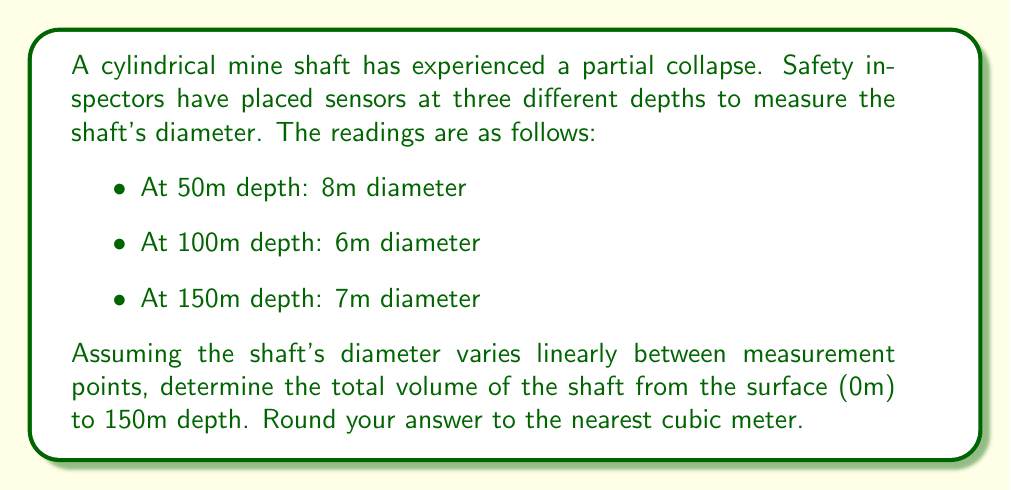Could you help me with this problem? To solve this problem, we'll follow these steps:

1) First, we need to determine the diameter at the surface (0m depth). We can do this by extrapolating the line between the first two measurements:

   $\frac{8m - 6m}{50m - 100m} = \frac{x - 8m}{0m - 50m}$

   $\frac{2m}{-50m} = \frac{x - 8m}{-50m}$

   $x - 8m = 2m$
   $x = 10m$

2) Now we have four points defining three sections of the shaft:
   - 0m to 50m: diameter changes from 10m to 8m
   - 50m to 100m: diameter changes from 8m to 6m
   - 100m to 150m: diameter changes from 6m to 7m

3) For each section, we can use the formula for the volume of a truncated cone:
   
   $V = \frac{1}{3}\pi h(R^2 + r^2 + Rr)$

   where $h$ is the height, $R$ is the radius at the base, and $r$ is the radius at the top.

4) Let's calculate the volume for each section:

   Section 1 (0m to 50m):
   $V_1 = \frac{1}{3}\pi \cdot 50 \cdot ((5^2 + 4^2 + 5 \cdot 4) = \frac{1}{3}\pi \cdot 50 \cdot 61 = 3189.14m^3$

   Section 2 (50m to 100m):
   $V_2 = \frac{1}{3}\pi \cdot 50 \cdot ((4^2 + 3^2 + 4 \cdot 3) = \frac{1}{3}\pi \cdot 50 \cdot 37 = 1932.08m^3$

   Section 3 (100m to 150m):
   $V_3 = \frac{1}{3}\pi \cdot 50 \cdot ((3^2 + 3.5^2 + 3 \cdot 3.5) = \frac{1}{3}\pi \cdot 50 \cdot 31.75 = 1658.12m^3$

5) The total volume is the sum of these three sections:

   $V_{total} = V_1 + V_2 + V_3 = 3189.14 + 1932.08 + 1658.12 = 6779.34m^3$

6) Rounding to the nearest cubic meter:

   $V_{total} \approx 6779m^3$
Answer: 6779 $m^3$ 